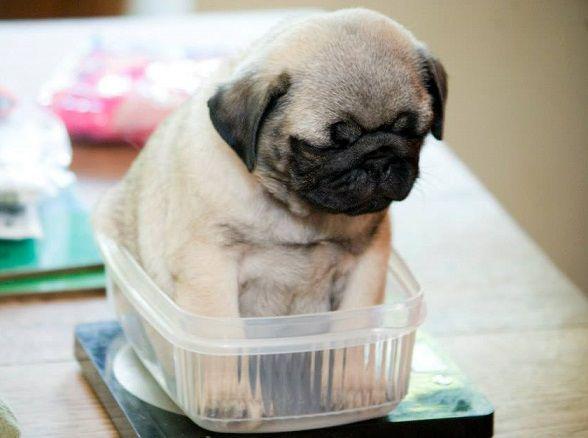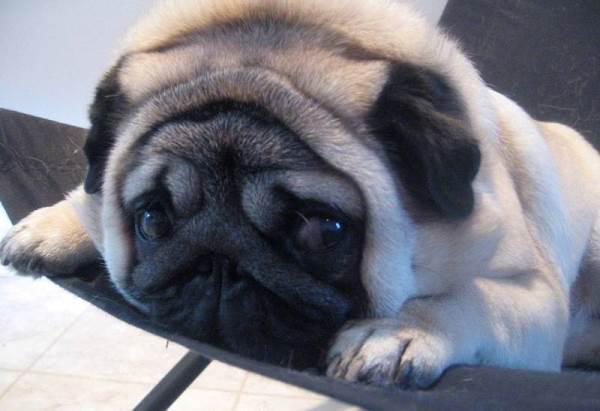The first image is the image on the left, the second image is the image on the right. Analyze the images presented: Is the assertion "At least one of the images shows a dog with a visible tongue outside of it's mouth." valid? Answer yes or no. No. The first image is the image on the left, the second image is the image on the right. For the images displayed, is the sentence "puppies are sleeping on their back with bellys exposed" factually correct? Answer yes or no. No. 